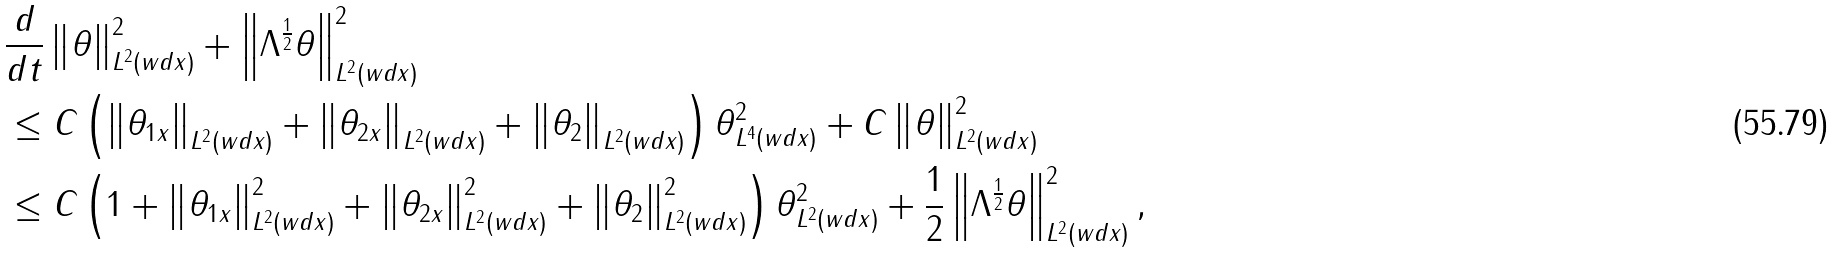Convert formula to latex. <formula><loc_0><loc_0><loc_500><loc_500>& \frac { d } { d t } \left \| \theta \right \| ^ { 2 } _ { L ^ { 2 } ( w d x ) } + \left \| \Lambda ^ { \frac { 1 } { 2 } } \theta \right \| ^ { 2 } _ { L ^ { 2 } ( w d x ) } \\ & \leq C \left ( \left \| \theta _ { 1 x } \right \| _ { L ^ { 2 } ( w d x ) } + \left \| \theta _ { 2 x } \right \| _ { L ^ { 2 } ( w d x ) } + \left \| \theta _ { 2 } \right \| _ { L ^ { 2 } ( w d x ) } \right ) \| \theta \| ^ { 2 } _ { L ^ { 4 } ( w d x ) } + C \left \| \theta \right \| ^ { 2 } _ { L ^ { 2 } ( w d x ) } \\ & \leq C \left ( 1 + \left \| \theta _ { 1 x } \right \| ^ { 2 } _ { L ^ { 2 } ( w d x ) } + \left \| \theta _ { 2 x } \right \| ^ { 2 } _ { L ^ { 2 } ( w d x ) } + \left \| \theta _ { 2 } \right \| ^ { 2 } _ { L ^ { 2 } ( w d x ) } \right ) \| \theta \| ^ { 2 } _ { L ^ { 2 } ( w d x ) } + \frac { 1 } { 2 } \left \| \Lambda ^ { \frac { 1 } { 2 } } \theta \right \| ^ { 2 } _ { L ^ { 2 } ( w d x ) } ,</formula> 